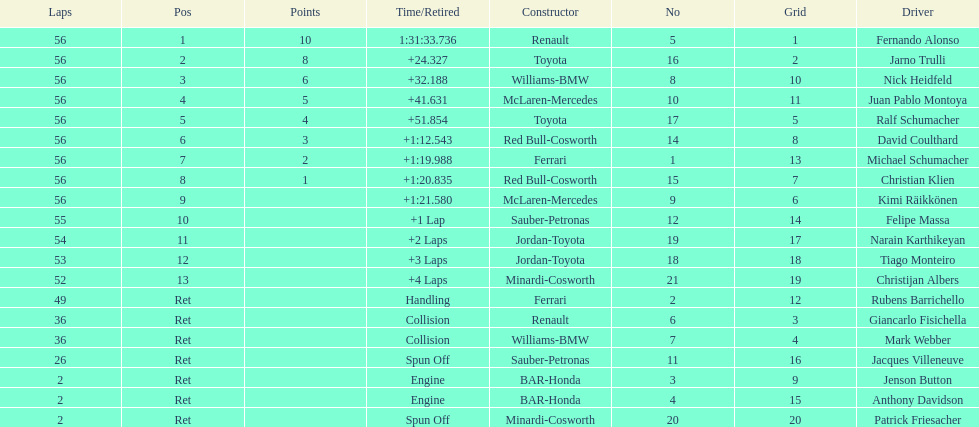How many bmws finished before webber? 1. 